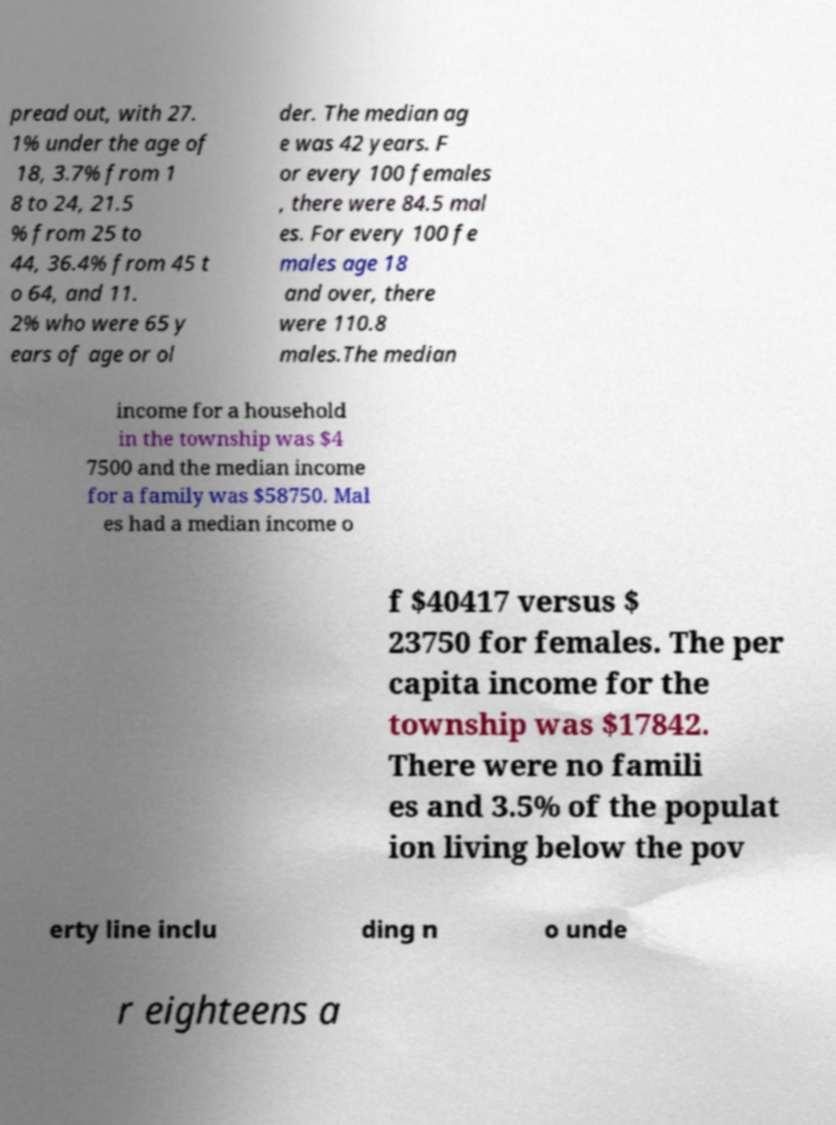I need the written content from this picture converted into text. Can you do that? pread out, with 27. 1% under the age of 18, 3.7% from 1 8 to 24, 21.5 % from 25 to 44, 36.4% from 45 t o 64, and 11. 2% who were 65 y ears of age or ol der. The median ag e was 42 years. F or every 100 females , there were 84.5 mal es. For every 100 fe males age 18 and over, there were 110.8 males.The median income for a household in the township was $4 7500 and the median income for a family was $58750. Mal es had a median income o f $40417 versus $ 23750 for females. The per capita income for the township was $17842. There were no famili es and 3.5% of the populat ion living below the pov erty line inclu ding n o unde r eighteens a 